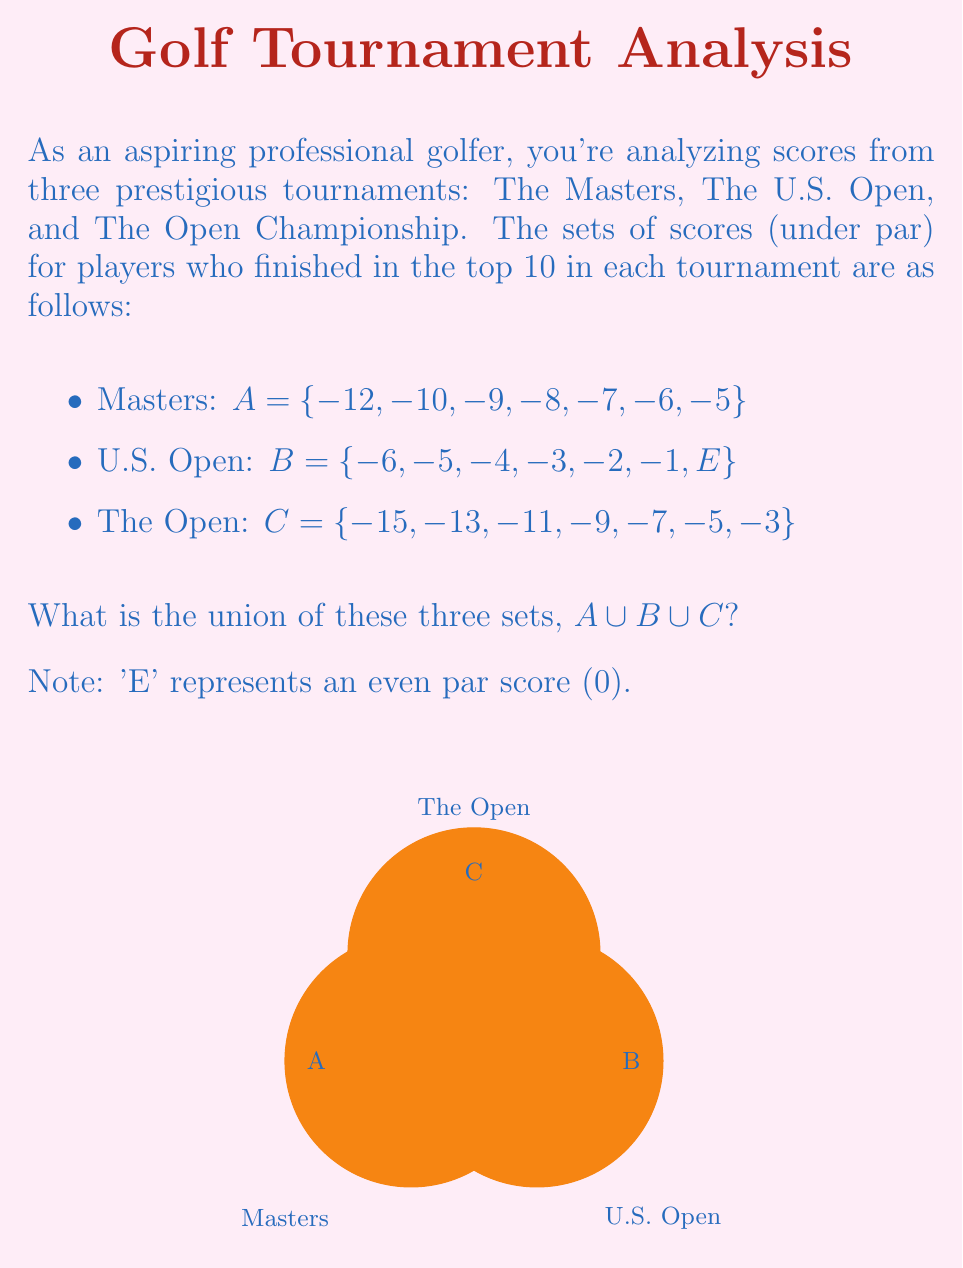Show me your answer to this math problem. To find the union of these three sets, we need to combine all unique elements from each set. Let's approach this step-by-step:

1) First, let's list out all the elements from set A:
   $A = \{-12, -10, -9, -8, -7, -6, -5\}$

2) Now, let's add any new elements from set B that aren't already in A:
   $A \cup B = \{-12, -10, -9, -8, -7, -6, -5, -4, -3, -2, -1, E\}$
   
   We added -4, -3, -2, -1, and E (0) from B.

3) Finally, let's add any new elements from set C that aren't in $A \cup B$:
   $A \cup B \cup C = \{-15, -13, -12, -11, -10, -9, -8, -7, -6, -5, -4, -3, -2, -1, E\}$
   
   We added -15, -13, and -11 from C.

4) Now we have all unique elements from all three sets.

5) To verify, let's check if all elements from each set are included:
   - A: All elements are present
   - B: All elements are present
   - C: All elements are present

Therefore, $A \cup B \cup C = \{-15, -13, -12, -11, -10, -9, -8, -7, -6, -5, -4, -3, -2, -1, E\}$
Answer: $\{-15, -13, -12, -11, -10, -9, -8, -7, -6, -5, -4, -3, -2, -1, E\}$ 